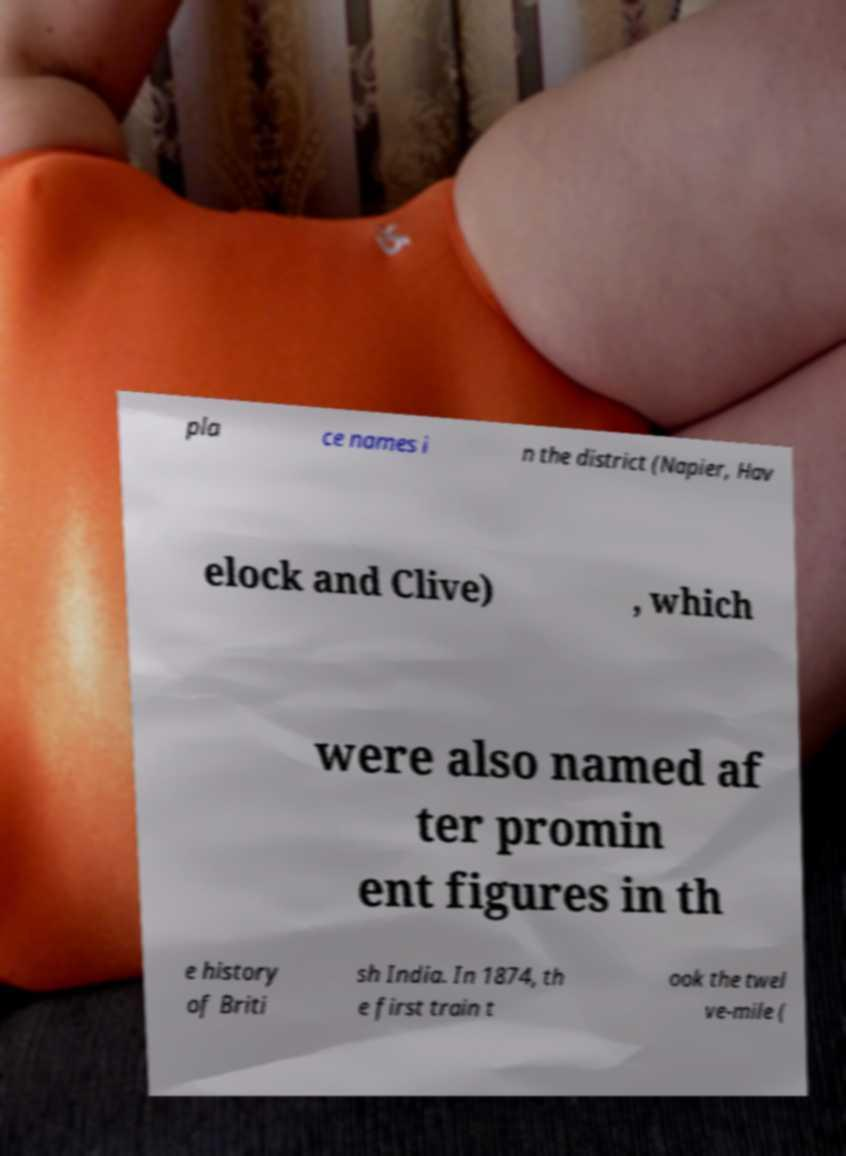Can you accurately transcribe the text from the provided image for me? pla ce names i n the district (Napier, Hav elock and Clive) , which were also named af ter promin ent figures in th e history of Briti sh India. In 1874, th e first train t ook the twel ve-mile ( 